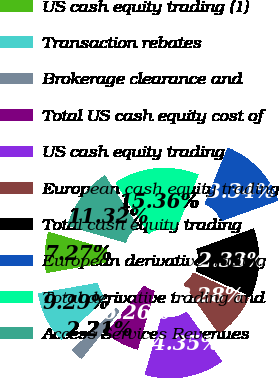Convert chart. <chart><loc_0><loc_0><loc_500><loc_500><pie_chart><fcel>US cash equity trading (1)<fcel>Transaction rebates<fcel>Brokerage clearance and<fcel>Total US cash equity cost of<fcel>US cash equity trading<fcel>European cash equity trading<fcel>Total cash equity trading<fcel>European derivative trading<fcel>Total derivative trading and<fcel>Access Services Revenues<nl><fcel>7.27%<fcel>9.29%<fcel>2.21%<fcel>6.26%<fcel>14.35%<fcel>8.28%<fcel>12.33%<fcel>13.34%<fcel>15.36%<fcel>11.32%<nl></chart> 